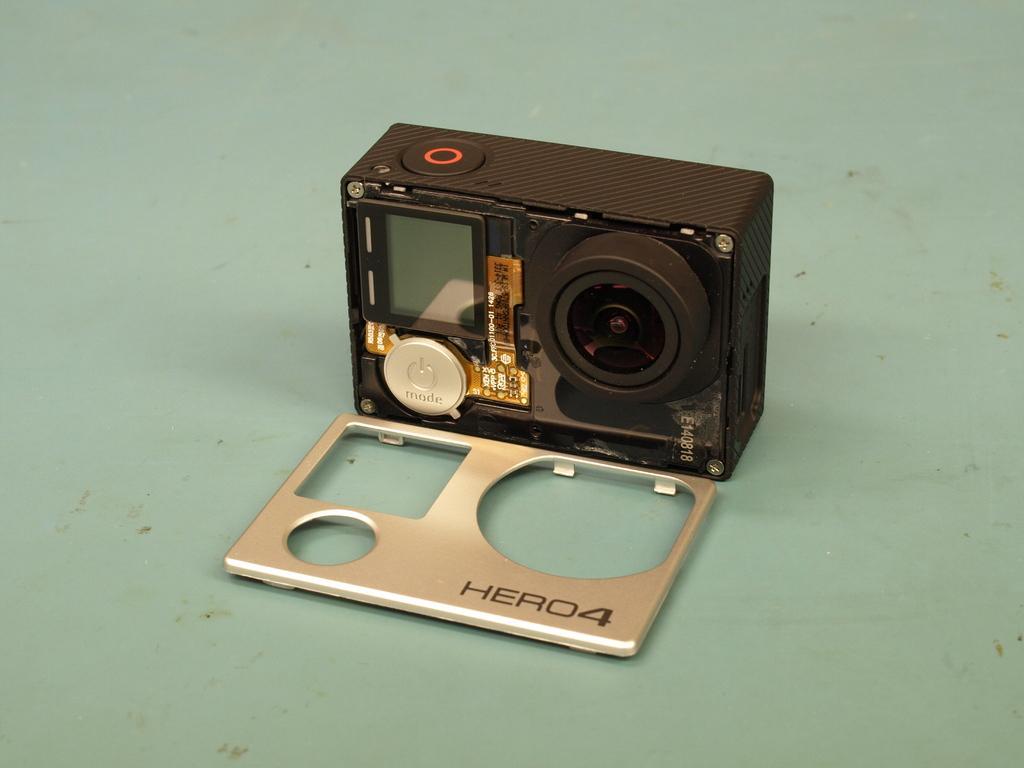Can you describe this image briefly? In this image in the center there is one camera, and at the bottom there is a table. 